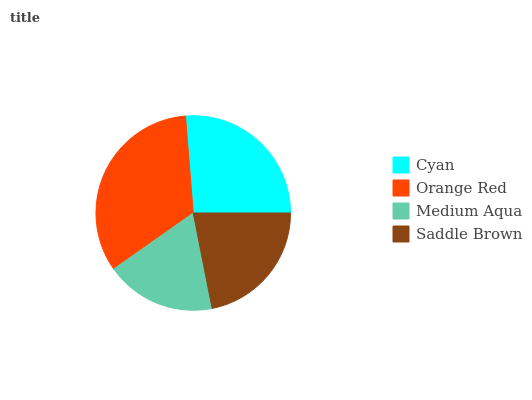Is Medium Aqua the minimum?
Answer yes or no. Yes. Is Orange Red the maximum?
Answer yes or no. Yes. Is Orange Red the minimum?
Answer yes or no. No. Is Medium Aqua the maximum?
Answer yes or no. No. Is Orange Red greater than Medium Aqua?
Answer yes or no. Yes. Is Medium Aqua less than Orange Red?
Answer yes or no. Yes. Is Medium Aqua greater than Orange Red?
Answer yes or no. No. Is Orange Red less than Medium Aqua?
Answer yes or no. No. Is Cyan the high median?
Answer yes or no. Yes. Is Saddle Brown the low median?
Answer yes or no. Yes. Is Orange Red the high median?
Answer yes or no. No. Is Orange Red the low median?
Answer yes or no. No. 